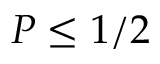<formula> <loc_0><loc_0><loc_500><loc_500>P \leq 1 / 2</formula> 